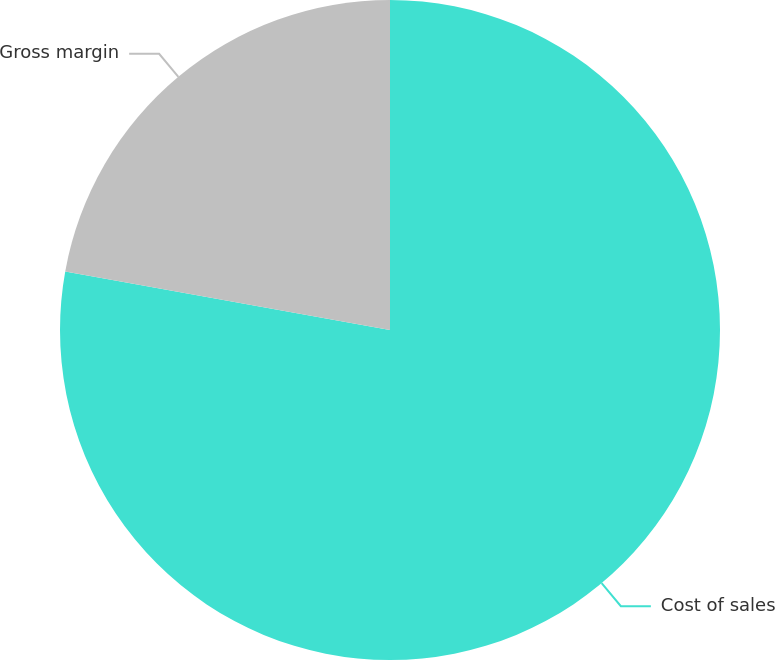Convert chart to OTSL. <chart><loc_0><loc_0><loc_500><loc_500><pie_chart><fcel>Cost of sales<fcel>Gross margin<nl><fcel>77.84%<fcel>22.16%<nl></chart> 